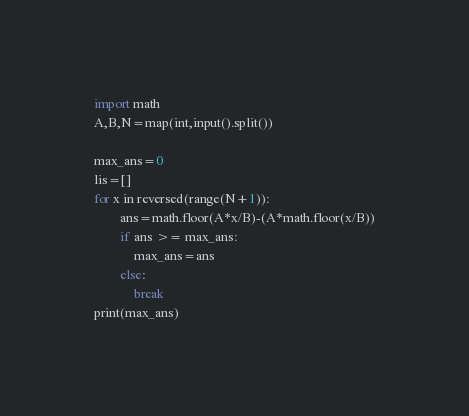<code> <loc_0><loc_0><loc_500><loc_500><_Python_>import math
A,B,N=map(int,input().split())

max_ans=0
lis=[]
for x in reversed(range(N+1)):
        ans=math.floor(A*x/B)-(A*math.floor(x/B))
        if ans >= max_ans:
            max_ans=ans
        else:
            break
print(max_ans)</code> 